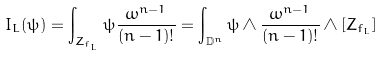<formula> <loc_0><loc_0><loc_500><loc_500>I _ { L } ( \psi ) = \int _ { Z _ { f _ { L } } } \psi \frac { \omega ^ { n - 1 } } { ( n - 1 ) ! } = \int _ { \mathbb { D } ^ { n } } \psi \wedge \frac { \omega ^ { n - 1 } } { ( n - 1 ) ! } \wedge [ Z _ { f _ { L } } ]</formula> 